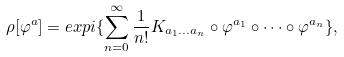Convert formula to latex. <formula><loc_0><loc_0><loc_500><loc_500>\rho [ \varphi ^ { a } ] = e x p i \{ \sum _ { n = 0 } ^ { \infty } \frac { 1 } { n ! } K _ { a _ { 1 } \dots a _ { n } } \circ \varphi ^ { a _ { 1 } } \circ \dots \circ \varphi ^ { a _ { n } } \} ,</formula> 